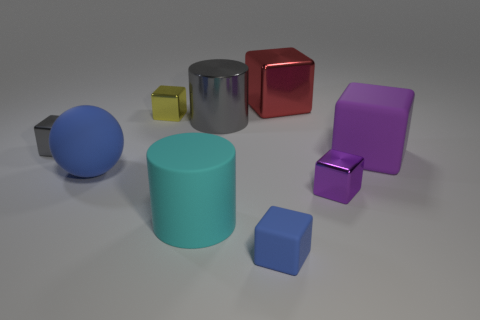The large matte thing on the right side of the gray metal object behind the block that is to the left of the yellow object is what shape?
Keep it short and to the point. Cube. What color is the big cylinder that is to the right of the big cyan object?
Keep it short and to the point. Gray. What number of things are metallic things that are behind the sphere or tiny purple shiny things to the right of the cyan rubber thing?
Give a very brief answer. 5. How many tiny gray metallic things have the same shape as the tiny purple object?
Your response must be concise. 1. There is a matte block that is the same size as the blue matte sphere; what is its color?
Keep it short and to the point. Purple. What is the color of the shiny object in front of the big cube that is in front of the tiny yellow thing that is on the left side of the small rubber object?
Your response must be concise. Purple. There is a red thing; does it have the same size as the blue rubber object in front of the cyan matte thing?
Offer a terse response. No. What number of objects are big balls or big gray things?
Provide a succinct answer. 2. Are there any tiny blue cubes made of the same material as the tiny gray object?
Keep it short and to the point. No. There is a object that is the same color as the sphere; what is its size?
Offer a very short reply. Small. 